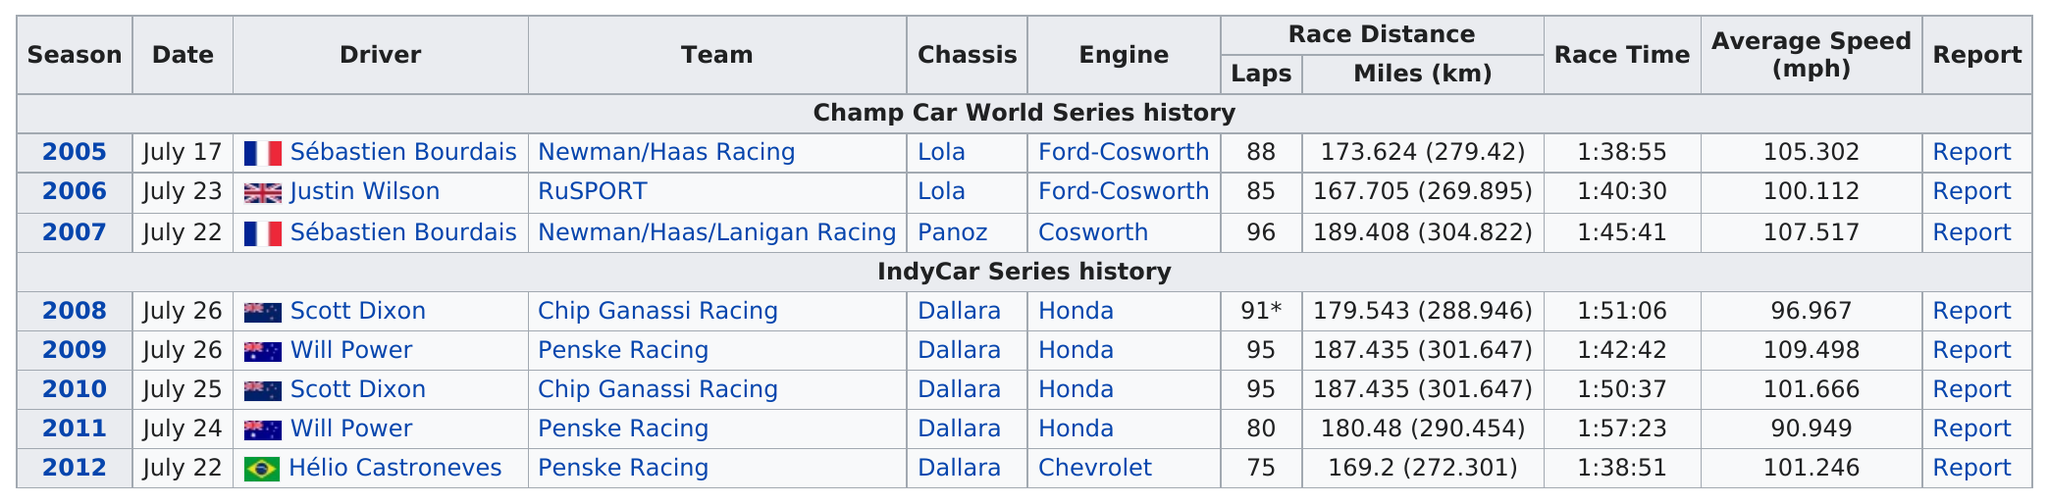Highlight a few significant elements in this photo. It is known that Hélio Castroneves was the only driver who operated a Chevrolet engine during his racing career. In the year prior to Russell, Newman/Haas Racing emerged as the victorious team in the Champ Car World Series. The completion of LASP by RUSPORT was 85%. Hélio Castroneves, the driver, raced the least amount of laps. Sébastien Bourdais won the Champ Car World Series a total of two times between 2005 and 2007. 